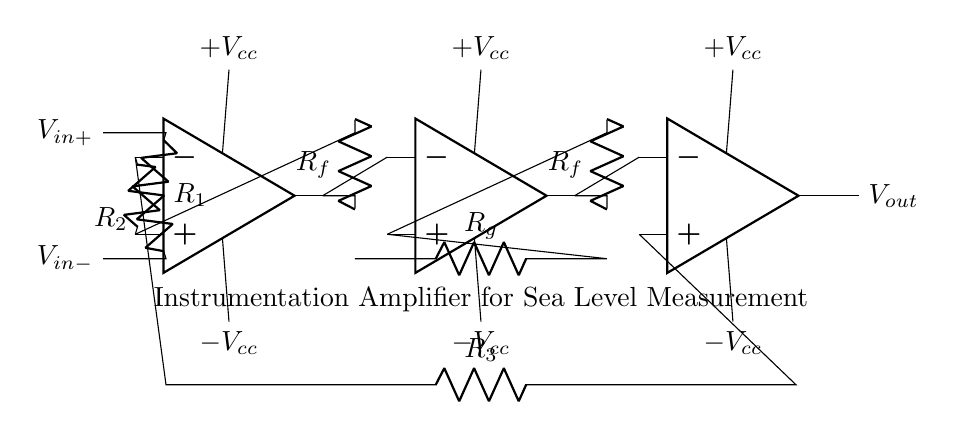What are the power supply voltages for the op-amps? The circuit shows power supply voltages of +V cc and -V cc for each op-amp, indicating that the op-amps can operate both on positive and negative voltages.
Answer: +V cc and -V cc How many op-amps are used in this circuit? The diagram provides three op-amps, labeled sequentially, which are connected to form the instrumentation amplifier.
Answer: Three What is the purpose of the feedback resistors in this circuit? Feedback resistors (R f) create a specific gain for the amplifier by routing a portion of the output back to the input, controlling how much the output will affect the operation of the op-amps.
Answer: Control gain Which components provide the input signals to the amplifier? The input signals are provided by R1 and R2, which connect to V in+ and V in-, allowing the amplifier to measure the difference between these two voltages.
Answer: R1 and R2 What does V out represent in this circuit? V out is the output voltage of the instrumentation amplifier, which reflects the amplified difference between the input voltages V in+ and V in-.
Answer: Output voltage How do the resistors R g influence the amplification? R g determines the gain of the instrumentation amplifier, influencing how much the input signal difference is amplified before it appears at the output, effectively setting the amplifier's responsiveness to changes.
Answer: Set gain What type of amplifier configuration is represented here? The configuration is an instrumentation amplifier, known for precise measurements and high input impedance, making it suitable for measuring small changes in signals like sea level changes.
Answer: Instrumentation amplifier 